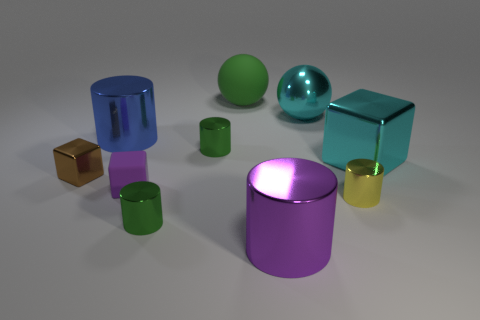What number of small cylinders are there? 3 